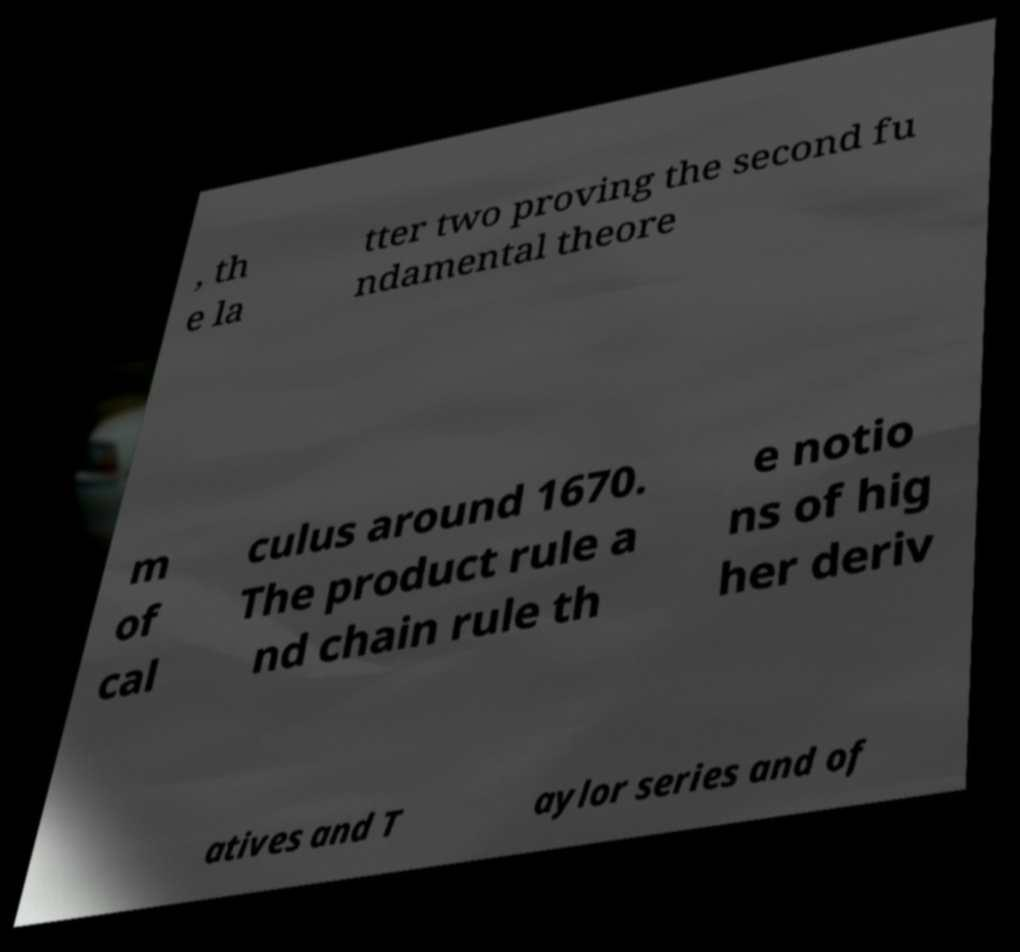What messages or text are displayed in this image? I need them in a readable, typed format. , th e la tter two proving the second fu ndamental theore m of cal culus around 1670. The product rule a nd chain rule th e notio ns of hig her deriv atives and T aylor series and of 